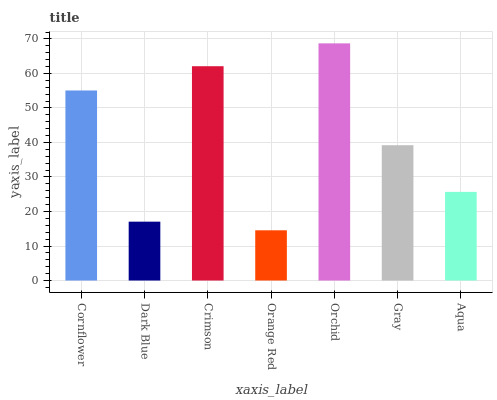Is Dark Blue the minimum?
Answer yes or no. No. Is Dark Blue the maximum?
Answer yes or no. No. Is Cornflower greater than Dark Blue?
Answer yes or no. Yes. Is Dark Blue less than Cornflower?
Answer yes or no. Yes. Is Dark Blue greater than Cornflower?
Answer yes or no. No. Is Cornflower less than Dark Blue?
Answer yes or no. No. Is Gray the high median?
Answer yes or no. Yes. Is Gray the low median?
Answer yes or no. Yes. Is Crimson the high median?
Answer yes or no. No. Is Dark Blue the low median?
Answer yes or no. No. 